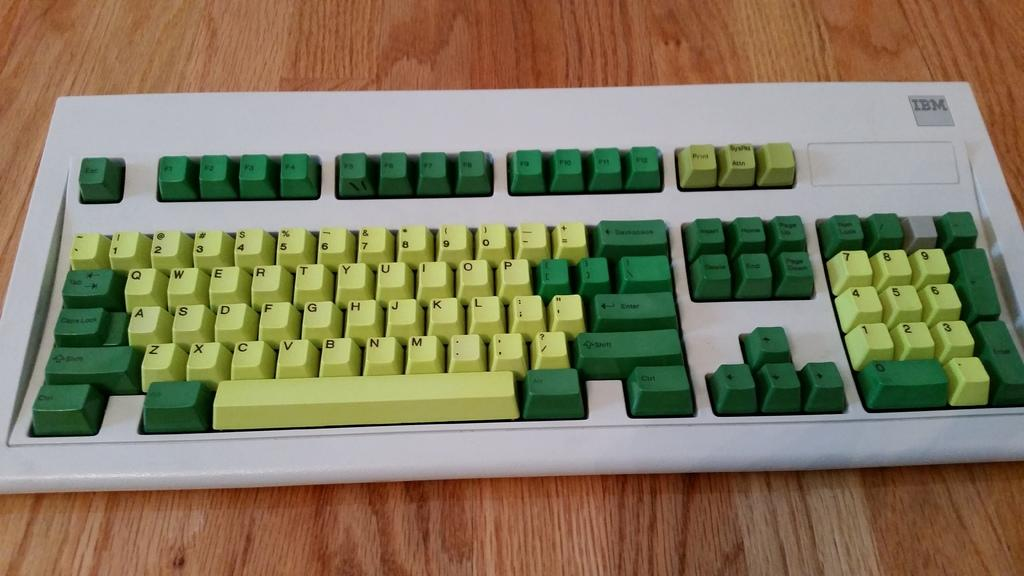<image>
Present a compact description of the photo's key features. Keyboard that is made from IBM in Yellow and Green Colors. 